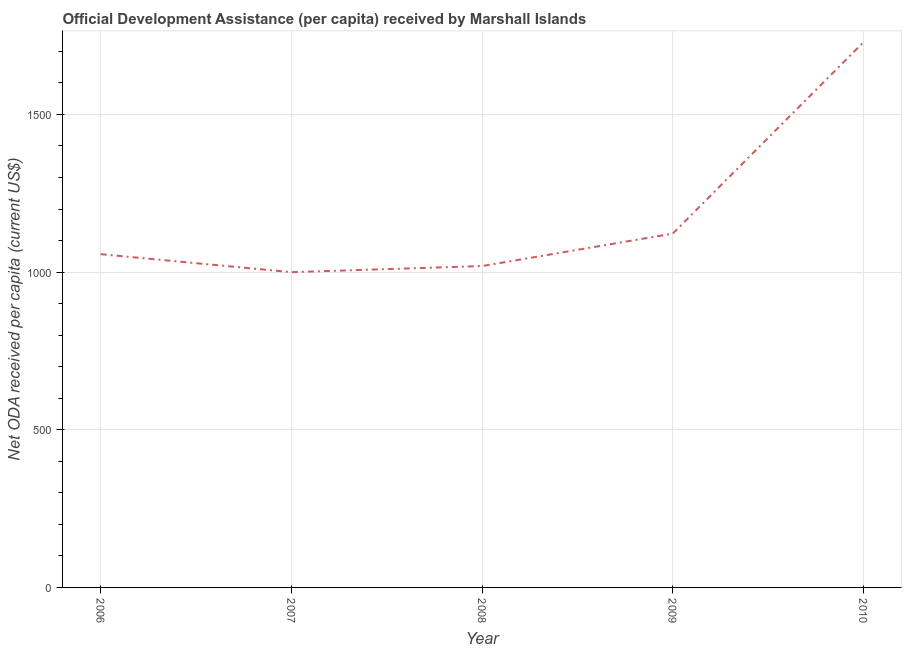What is the net oda received per capita in 2010?
Your answer should be very brief. 1728.66. Across all years, what is the maximum net oda received per capita?
Your answer should be very brief. 1728.66. Across all years, what is the minimum net oda received per capita?
Your response must be concise. 999.69. In which year was the net oda received per capita minimum?
Offer a very short reply. 2007. What is the sum of the net oda received per capita?
Offer a terse response. 5926.24. What is the difference between the net oda received per capita in 2007 and 2010?
Ensure brevity in your answer.  -728.96. What is the average net oda received per capita per year?
Give a very brief answer. 1185.25. What is the median net oda received per capita?
Offer a terse response. 1056.84. Do a majority of the years between 2010 and 2007 (inclusive) have net oda received per capita greater than 600 US$?
Your response must be concise. Yes. What is the ratio of the net oda received per capita in 2007 to that in 2008?
Ensure brevity in your answer.  0.98. What is the difference between the highest and the second highest net oda received per capita?
Your answer should be very brief. 606.74. Is the sum of the net oda received per capita in 2007 and 2009 greater than the maximum net oda received per capita across all years?
Make the answer very short. Yes. What is the difference between the highest and the lowest net oda received per capita?
Offer a terse response. 728.96. In how many years, is the net oda received per capita greater than the average net oda received per capita taken over all years?
Offer a very short reply. 1. Does the net oda received per capita monotonically increase over the years?
Offer a very short reply. No. Are the values on the major ticks of Y-axis written in scientific E-notation?
Your response must be concise. No. Does the graph contain grids?
Make the answer very short. Yes. What is the title of the graph?
Offer a terse response. Official Development Assistance (per capita) received by Marshall Islands. What is the label or title of the Y-axis?
Offer a terse response. Net ODA received per capita (current US$). What is the Net ODA received per capita (current US$) in 2006?
Ensure brevity in your answer.  1056.84. What is the Net ODA received per capita (current US$) in 2007?
Your response must be concise. 999.69. What is the Net ODA received per capita (current US$) in 2008?
Make the answer very short. 1019.13. What is the Net ODA received per capita (current US$) in 2009?
Offer a very short reply. 1121.92. What is the Net ODA received per capita (current US$) in 2010?
Make the answer very short. 1728.66. What is the difference between the Net ODA received per capita (current US$) in 2006 and 2007?
Offer a terse response. 57.14. What is the difference between the Net ODA received per capita (current US$) in 2006 and 2008?
Your answer should be compact. 37.71. What is the difference between the Net ODA received per capita (current US$) in 2006 and 2009?
Ensure brevity in your answer.  -65.08. What is the difference between the Net ODA received per capita (current US$) in 2006 and 2010?
Your response must be concise. -671.82. What is the difference between the Net ODA received per capita (current US$) in 2007 and 2008?
Keep it short and to the point. -19.44. What is the difference between the Net ODA received per capita (current US$) in 2007 and 2009?
Your response must be concise. -122.23. What is the difference between the Net ODA received per capita (current US$) in 2007 and 2010?
Your answer should be very brief. -728.96. What is the difference between the Net ODA received per capita (current US$) in 2008 and 2009?
Keep it short and to the point. -102.79. What is the difference between the Net ODA received per capita (current US$) in 2008 and 2010?
Offer a very short reply. -709.53. What is the difference between the Net ODA received per capita (current US$) in 2009 and 2010?
Provide a short and direct response. -606.74. What is the ratio of the Net ODA received per capita (current US$) in 2006 to that in 2007?
Your answer should be very brief. 1.06. What is the ratio of the Net ODA received per capita (current US$) in 2006 to that in 2008?
Offer a terse response. 1.04. What is the ratio of the Net ODA received per capita (current US$) in 2006 to that in 2009?
Offer a very short reply. 0.94. What is the ratio of the Net ODA received per capita (current US$) in 2006 to that in 2010?
Give a very brief answer. 0.61. What is the ratio of the Net ODA received per capita (current US$) in 2007 to that in 2009?
Your answer should be compact. 0.89. What is the ratio of the Net ODA received per capita (current US$) in 2007 to that in 2010?
Provide a succinct answer. 0.58. What is the ratio of the Net ODA received per capita (current US$) in 2008 to that in 2009?
Provide a succinct answer. 0.91. What is the ratio of the Net ODA received per capita (current US$) in 2008 to that in 2010?
Provide a short and direct response. 0.59. What is the ratio of the Net ODA received per capita (current US$) in 2009 to that in 2010?
Your answer should be compact. 0.65. 